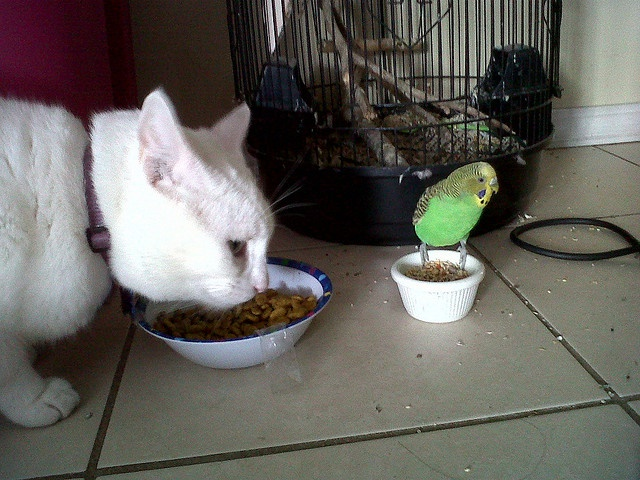Describe the objects in this image and their specific colors. I can see cat in purple, lightgray, darkgray, and gray tones, bowl in purple, black, darkgray, gray, and maroon tones, bowl in purple, white, darkgray, and gray tones, and bird in purple, olive, and lightgreen tones in this image. 